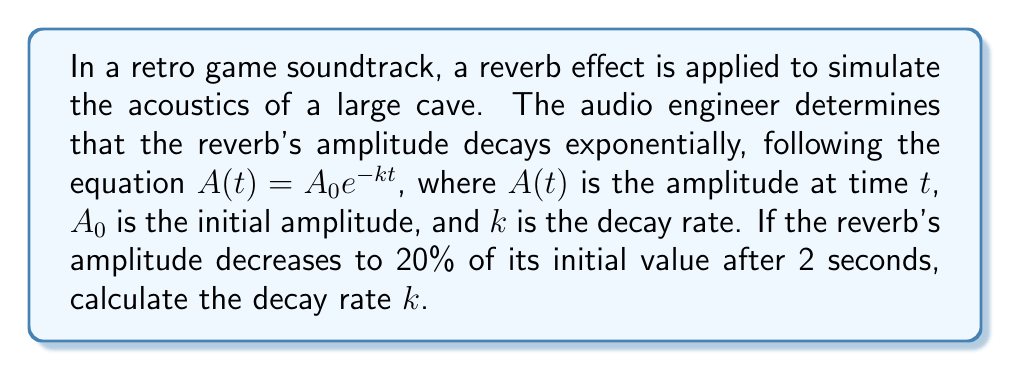What is the answer to this math problem? Let's approach this step-by-step:

1) We're given the exponential decay equation:
   $A(t) = A_0 e^{-kt}$

2) We know that after 2 seconds, the amplitude is 20% of the initial value. Let's express this mathematically:
   $A(2) = 0.2A_0$

3) Substituting these values into our original equation:
   $0.2A_0 = A_0 e^{-k(2)}$

4) We can simplify this by dividing both sides by $A_0$:
   $0.2 = e^{-2k}$

5) Now, let's take the natural logarithm of both sides:
   $\ln(0.2) = \ln(e^{-2k})$

6) The right side simplifies due to the properties of logarithms:
   $\ln(0.2) = -2k$

7) Solve for $k$:
   $k = -\frac{\ln(0.2)}{2}$

8) Calculate the value:
   $k = -\frac{\ln(0.2)}{2} \approx 0.8047$

Therefore, the decay rate $k$ is approximately 0.8047 per second.
Answer: $k \approx 0.8047$ s^-1 